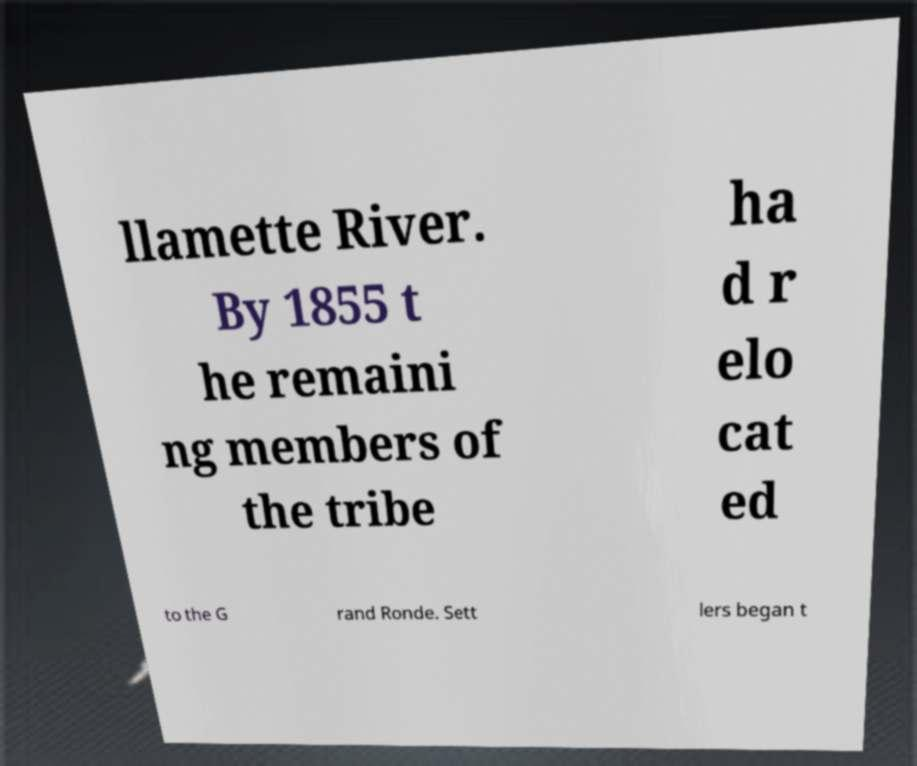Please identify and transcribe the text found in this image. llamette River. By 1855 t he remaini ng members of the tribe ha d r elo cat ed to the G rand Ronde. Sett lers began t 